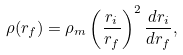Convert formula to latex. <formula><loc_0><loc_0><loc_500><loc_500>\rho ( r _ { f } ) = \rho _ { m } \left ( \frac { r _ { i } } { r _ { f } } \right ) ^ { 2 } \frac { d r _ { i } } { d r _ { f } } ,</formula> 